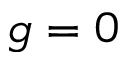<formula> <loc_0><loc_0><loc_500><loc_500>g = 0</formula> 